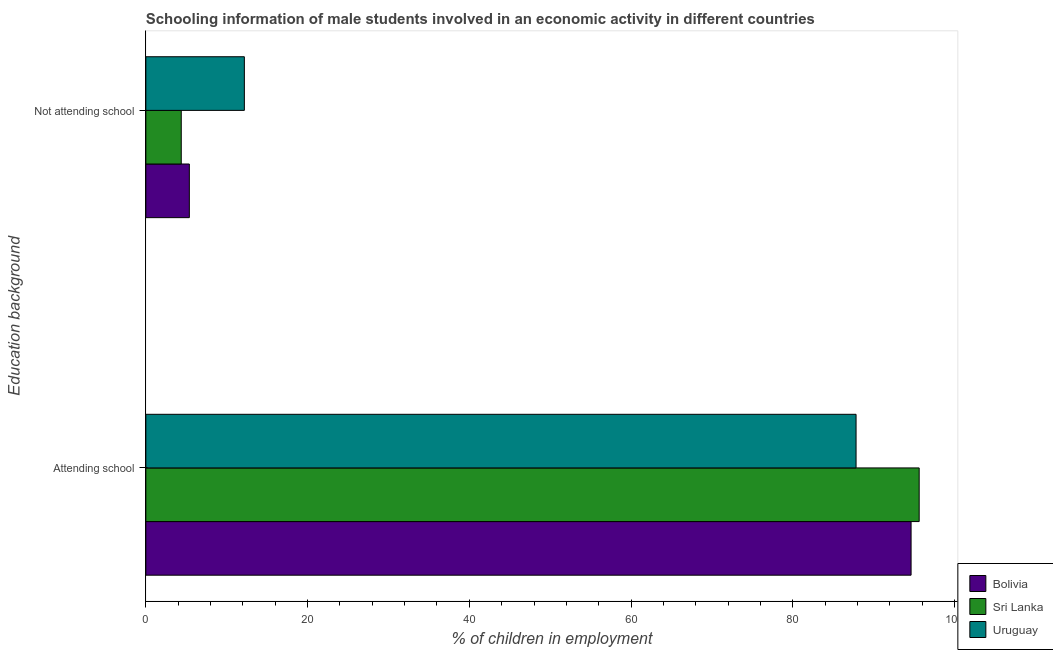How many groups of bars are there?
Offer a terse response. 2. How many bars are there on the 2nd tick from the bottom?
Your answer should be compact. 3. What is the label of the 2nd group of bars from the top?
Provide a succinct answer. Attending school. What is the percentage of employed males who are not attending school in Uruguay?
Offer a very short reply. 12.18. Across all countries, what is the maximum percentage of employed males who are attending school?
Your answer should be very brief. 95.62. Across all countries, what is the minimum percentage of employed males who are not attending school?
Your answer should be very brief. 4.38. In which country was the percentage of employed males who are attending school maximum?
Provide a succinct answer. Sri Lanka. In which country was the percentage of employed males who are attending school minimum?
Your response must be concise. Uruguay. What is the total percentage of employed males who are attending school in the graph?
Offer a terse response. 278.06. What is the difference between the percentage of employed males who are not attending school in Sri Lanka and that in Bolivia?
Ensure brevity in your answer.  -1. What is the difference between the percentage of employed males who are not attending school in Sri Lanka and the percentage of employed males who are attending school in Uruguay?
Your answer should be very brief. -83.44. What is the average percentage of employed males who are not attending school per country?
Your answer should be compact. 7.31. What is the difference between the percentage of employed males who are attending school and percentage of employed males who are not attending school in Sri Lanka?
Your response must be concise. 91.24. What is the ratio of the percentage of employed males who are not attending school in Bolivia to that in Sri Lanka?
Your answer should be very brief. 1.23. In how many countries, is the percentage of employed males who are not attending school greater than the average percentage of employed males who are not attending school taken over all countries?
Give a very brief answer. 1. What does the 2nd bar from the top in Attending school represents?
Make the answer very short. Sri Lanka. What does the 1st bar from the bottom in Attending school represents?
Your answer should be very brief. Bolivia. How many bars are there?
Your answer should be very brief. 6. Are all the bars in the graph horizontal?
Your response must be concise. Yes. How many countries are there in the graph?
Provide a short and direct response. 3. What is the difference between two consecutive major ticks on the X-axis?
Give a very brief answer. 20. Does the graph contain any zero values?
Your answer should be very brief. No. How many legend labels are there?
Provide a succinct answer. 3. How are the legend labels stacked?
Keep it short and to the point. Vertical. What is the title of the graph?
Ensure brevity in your answer.  Schooling information of male students involved in an economic activity in different countries. What is the label or title of the X-axis?
Your response must be concise. % of children in employment. What is the label or title of the Y-axis?
Ensure brevity in your answer.  Education background. What is the % of children in employment in Bolivia in Attending school?
Your response must be concise. 94.62. What is the % of children in employment of Sri Lanka in Attending school?
Provide a succinct answer. 95.62. What is the % of children in employment of Uruguay in Attending school?
Ensure brevity in your answer.  87.82. What is the % of children in employment in Bolivia in Not attending school?
Your answer should be very brief. 5.38. What is the % of children in employment in Sri Lanka in Not attending school?
Give a very brief answer. 4.38. What is the % of children in employment of Uruguay in Not attending school?
Offer a very short reply. 12.18. Across all Education background, what is the maximum % of children in employment of Bolivia?
Your answer should be very brief. 94.62. Across all Education background, what is the maximum % of children in employment in Sri Lanka?
Your answer should be very brief. 95.62. Across all Education background, what is the maximum % of children in employment in Uruguay?
Offer a terse response. 87.82. Across all Education background, what is the minimum % of children in employment in Bolivia?
Keep it short and to the point. 5.38. Across all Education background, what is the minimum % of children in employment of Sri Lanka?
Ensure brevity in your answer.  4.38. Across all Education background, what is the minimum % of children in employment in Uruguay?
Give a very brief answer. 12.18. What is the total % of children in employment in Sri Lanka in the graph?
Keep it short and to the point. 100. What is the total % of children in employment in Uruguay in the graph?
Your answer should be very brief. 100. What is the difference between the % of children in employment in Bolivia in Attending school and that in Not attending school?
Provide a succinct answer. 89.24. What is the difference between the % of children in employment of Sri Lanka in Attending school and that in Not attending school?
Provide a succinct answer. 91.24. What is the difference between the % of children in employment of Uruguay in Attending school and that in Not attending school?
Provide a succinct answer. 75.64. What is the difference between the % of children in employment of Bolivia in Attending school and the % of children in employment of Sri Lanka in Not attending school?
Offer a very short reply. 90.24. What is the difference between the % of children in employment in Bolivia in Attending school and the % of children in employment in Uruguay in Not attending school?
Make the answer very short. 82.44. What is the difference between the % of children in employment in Sri Lanka in Attending school and the % of children in employment in Uruguay in Not attending school?
Provide a short and direct response. 83.44. What is the difference between the % of children in employment of Bolivia and % of children in employment of Sri Lanka in Attending school?
Offer a terse response. -1. What is the difference between the % of children in employment in Bolivia and % of children in employment in Uruguay in Attending school?
Offer a terse response. 6.8. What is the difference between the % of children in employment in Sri Lanka and % of children in employment in Uruguay in Attending school?
Give a very brief answer. 7.8. What is the difference between the % of children in employment in Bolivia and % of children in employment in Sri Lanka in Not attending school?
Give a very brief answer. 1. What is the difference between the % of children in employment in Bolivia and % of children in employment in Uruguay in Not attending school?
Provide a succinct answer. -6.8. What is the difference between the % of children in employment of Sri Lanka and % of children in employment of Uruguay in Not attending school?
Your answer should be very brief. -7.8. What is the ratio of the % of children in employment in Bolivia in Attending school to that in Not attending school?
Provide a short and direct response. 17.59. What is the ratio of the % of children in employment of Sri Lanka in Attending school to that in Not attending school?
Give a very brief answer. 21.84. What is the ratio of the % of children in employment of Uruguay in Attending school to that in Not attending school?
Provide a succinct answer. 7.21. What is the difference between the highest and the second highest % of children in employment of Bolivia?
Make the answer very short. 89.24. What is the difference between the highest and the second highest % of children in employment of Sri Lanka?
Your answer should be compact. 91.24. What is the difference between the highest and the second highest % of children in employment of Uruguay?
Your answer should be very brief. 75.64. What is the difference between the highest and the lowest % of children in employment in Bolivia?
Give a very brief answer. 89.24. What is the difference between the highest and the lowest % of children in employment in Sri Lanka?
Your answer should be very brief. 91.24. What is the difference between the highest and the lowest % of children in employment of Uruguay?
Offer a terse response. 75.64. 